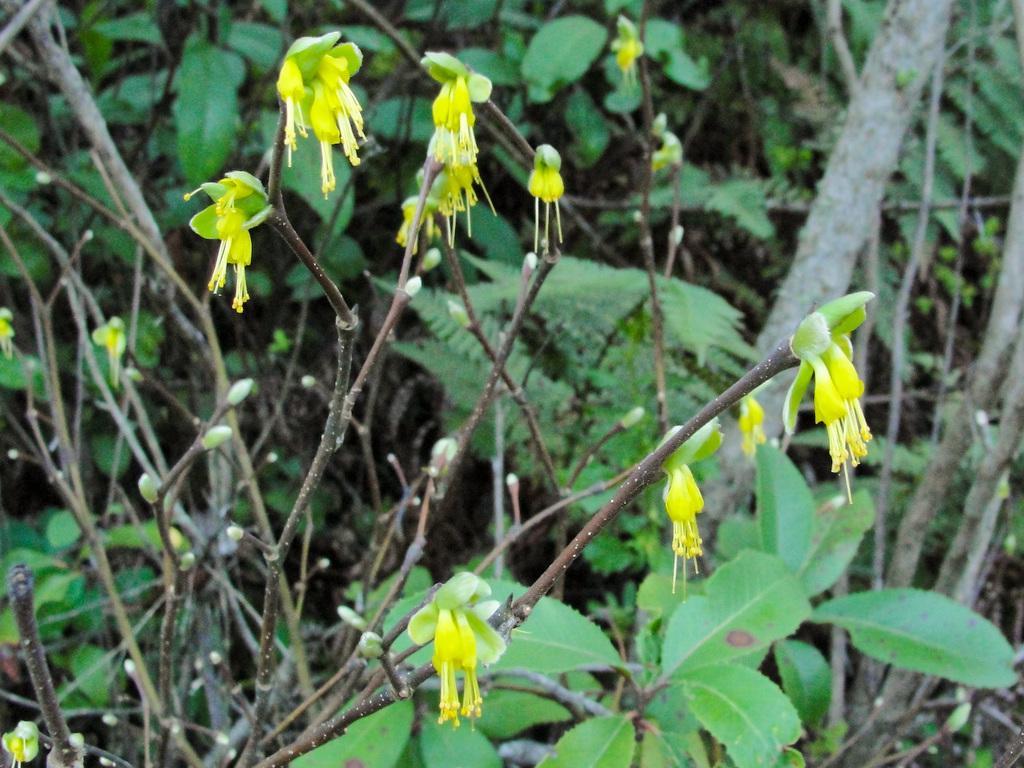Describe this image in one or two sentences. In the foreground of the picture there are plants, flowers and buds. The background is blurred. In the background there are trees. 